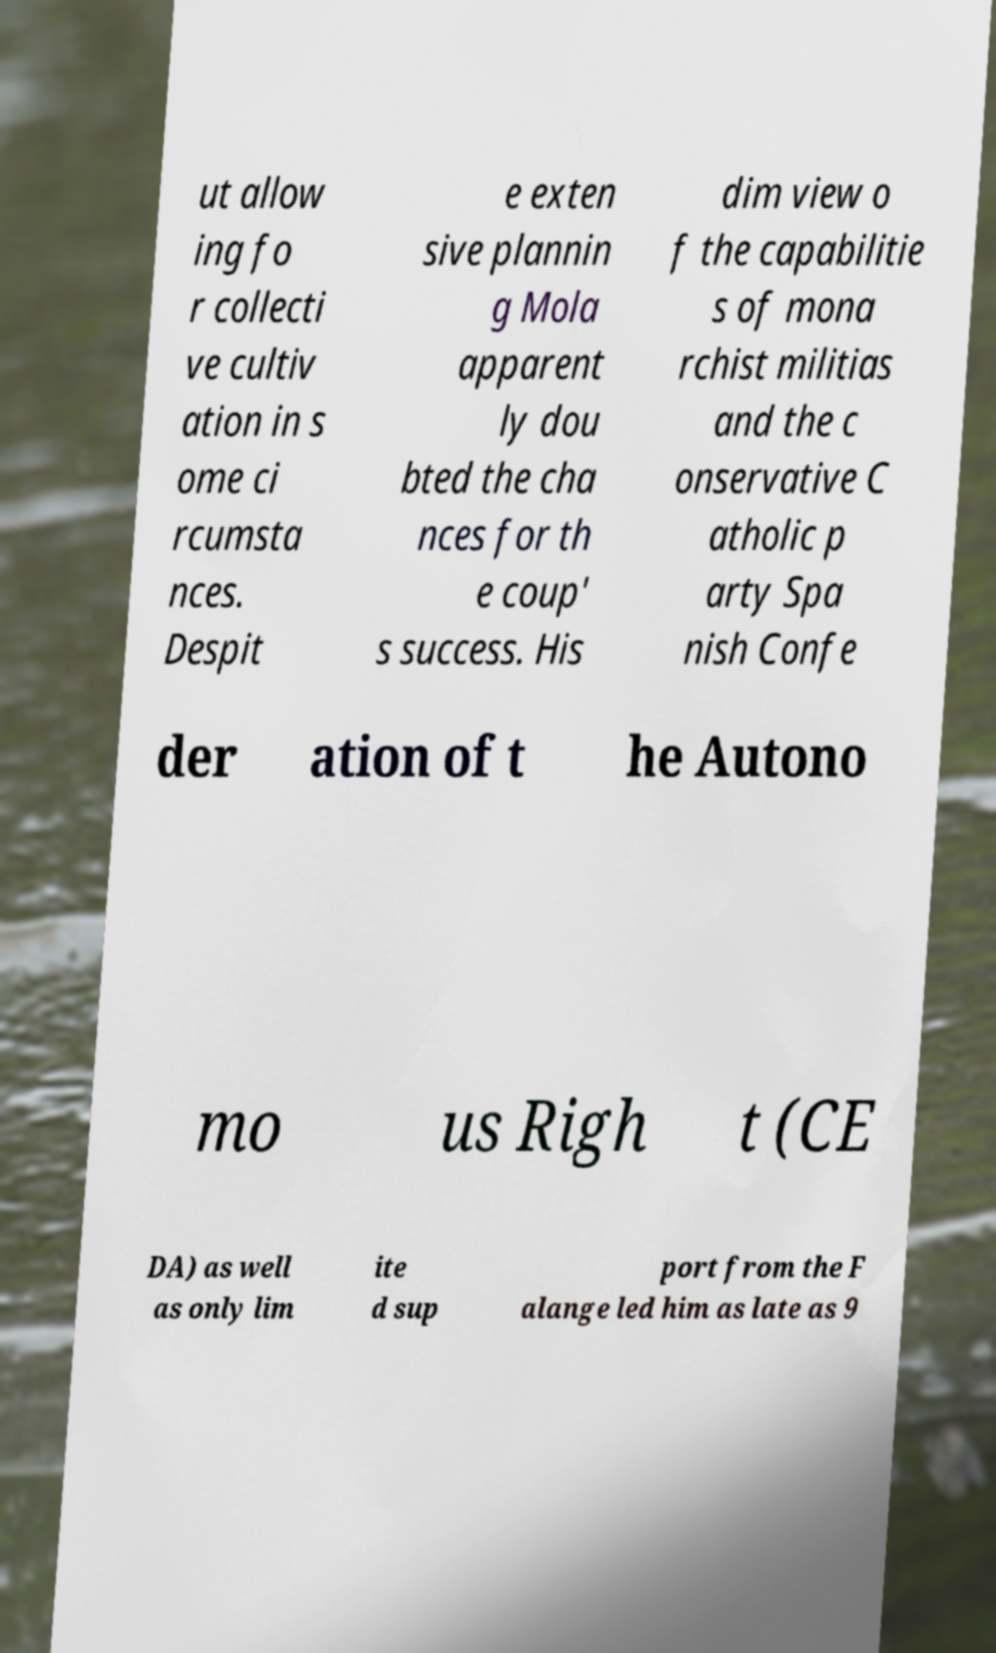What messages or text are displayed in this image? I need them in a readable, typed format. ut allow ing fo r collecti ve cultiv ation in s ome ci rcumsta nces. Despit e exten sive plannin g Mola apparent ly dou bted the cha nces for th e coup' s success. His dim view o f the capabilitie s of mona rchist militias and the c onservative C atholic p arty Spa nish Confe der ation of t he Autono mo us Righ t (CE DA) as well as only lim ite d sup port from the F alange led him as late as 9 